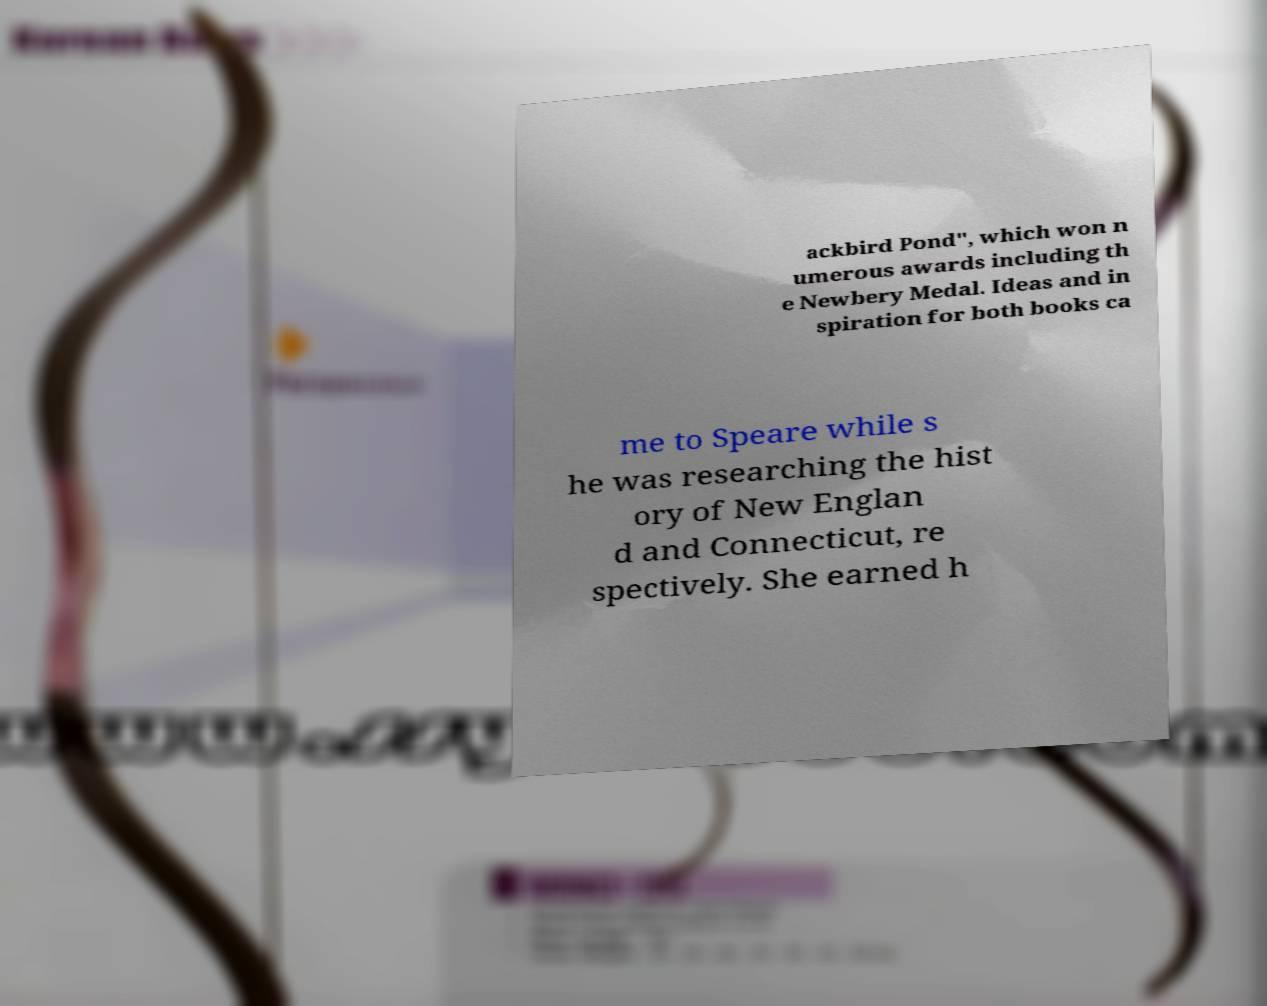Could you extract and type out the text from this image? ackbird Pond", which won n umerous awards including th e Newbery Medal. Ideas and in spiration for both books ca me to Speare while s he was researching the hist ory of New Englan d and Connecticut, re spectively. She earned h 